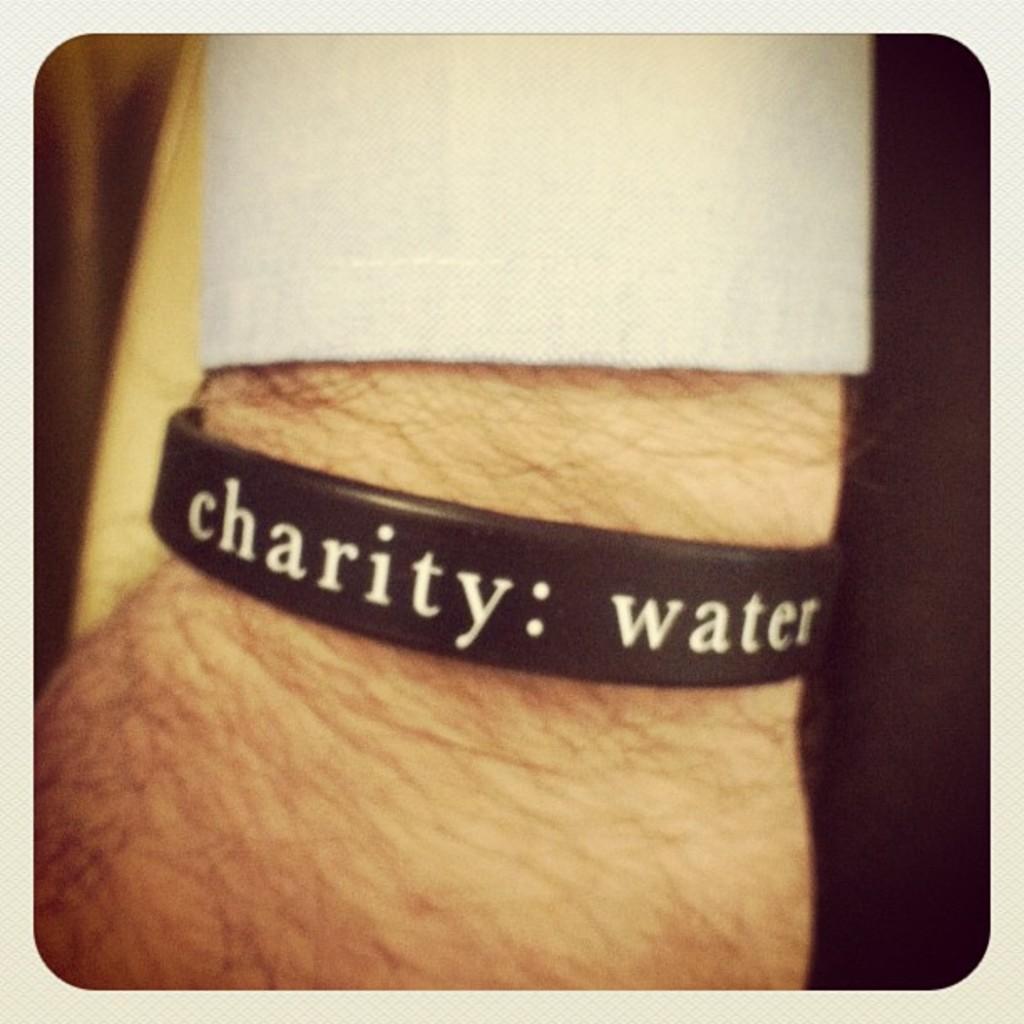In one or two sentences, can you explain what this image depicts? In this image the background is dark. In the middle of the image there is a person's hand with a wrist band on the wrist with a text on it. 